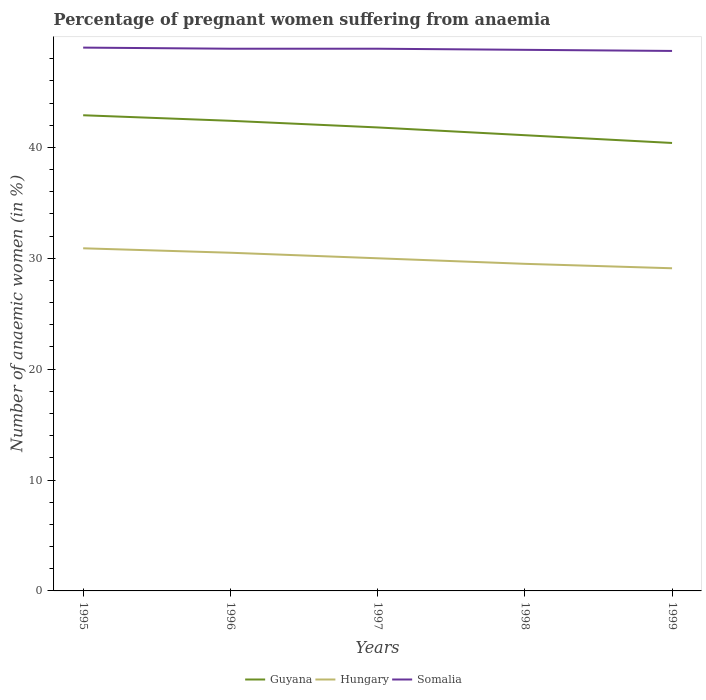How many different coloured lines are there?
Your answer should be very brief. 3. Is the number of lines equal to the number of legend labels?
Make the answer very short. Yes. Across all years, what is the maximum number of anaemic women in Somalia?
Make the answer very short. 48.7. In which year was the number of anaemic women in Somalia maximum?
Give a very brief answer. 1999. What is the total number of anaemic women in Guyana in the graph?
Make the answer very short. 1.1. What is the difference between the highest and the second highest number of anaemic women in Hungary?
Your answer should be very brief. 1.8. How many lines are there?
Provide a succinct answer. 3. Are the values on the major ticks of Y-axis written in scientific E-notation?
Give a very brief answer. No. Where does the legend appear in the graph?
Your answer should be compact. Bottom center. What is the title of the graph?
Keep it short and to the point. Percentage of pregnant women suffering from anaemia. Does "Tajikistan" appear as one of the legend labels in the graph?
Make the answer very short. No. What is the label or title of the X-axis?
Offer a very short reply. Years. What is the label or title of the Y-axis?
Your answer should be very brief. Number of anaemic women (in %). What is the Number of anaemic women (in %) in Guyana in 1995?
Your response must be concise. 42.9. What is the Number of anaemic women (in %) of Hungary in 1995?
Keep it short and to the point. 30.9. What is the Number of anaemic women (in %) in Guyana in 1996?
Keep it short and to the point. 42.4. What is the Number of anaemic women (in %) in Hungary in 1996?
Your answer should be very brief. 30.5. What is the Number of anaemic women (in %) of Somalia in 1996?
Your answer should be very brief. 48.9. What is the Number of anaemic women (in %) in Guyana in 1997?
Your answer should be compact. 41.8. What is the Number of anaemic women (in %) of Somalia in 1997?
Offer a terse response. 48.9. What is the Number of anaemic women (in %) of Guyana in 1998?
Your answer should be very brief. 41.1. What is the Number of anaemic women (in %) of Hungary in 1998?
Ensure brevity in your answer.  29.5. What is the Number of anaemic women (in %) in Somalia in 1998?
Offer a very short reply. 48.8. What is the Number of anaemic women (in %) of Guyana in 1999?
Make the answer very short. 40.4. What is the Number of anaemic women (in %) of Hungary in 1999?
Your answer should be compact. 29.1. What is the Number of anaemic women (in %) in Somalia in 1999?
Keep it short and to the point. 48.7. Across all years, what is the maximum Number of anaemic women (in %) of Guyana?
Your response must be concise. 42.9. Across all years, what is the maximum Number of anaemic women (in %) of Hungary?
Offer a very short reply. 30.9. Across all years, what is the maximum Number of anaemic women (in %) in Somalia?
Ensure brevity in your answer.  49. Across all years, what is the minimum Number of anaemic women (in %) in Guyana?
Keep it short and to the point. 40.4. Across all years, what is the minimum Number of anaemic women (in %) of Hungary?
Provide a succinct answer. 29.1. Across all years, what is the minimum Number of anaemic women (in %) of Somalia?
Make the answer very short. 48.7. What is the total Number of anaemic women (in %) of Guyana in the graph?
Ensure brevity in your answer.  208.6. What is the total Number of anaemic women (in %) in Hungary in the graph?
Ensure brevity in your answer.  150. What is the total Number of anaemic women (in %) in Somalia in the graph?
Keep it short and to the point. 244.3. What is the difference between the Number of anaemic women (in %) of Hungary in 1995 and that in 1996?
Keep it short and to the point. 0.4. What is the difference between the Number of anaemic women (in %) in Somalia in 1995 and that in 1996?
Offer a terse response. 0.1. What is the difference between the Number of anaemic women (in %) in Guyana in 1995 and that in 1997?
Provide a short and direct response. 1.1. What is the difference between the Number of anaemic women (in %) in Hungary in 1995 and that in 1997?
Keep it short and to the point. 0.9. What is the difference between the Number of anaemic women (in %) of Somalia in 1995 and that in 1997?
Make the answer very short. 0.1. What is the difference between the Number of anaemic women (in %) of Somalia in 1995 and that in 1998?
Make the answer very short. 0.2. What is the difference between the Number of anaemic women (in %) of Guyana in 1995 and that in 1999?
Ensure brevity in your answer.  2.5. What is the difference between the Number of anaemic women (in %) of Somalia in 1995 and that in 1999?
Make the answer very short. 0.3. What is the difference between the Number of anaemic women (in %) of Guyana in 1996 and that in 1997?
Ensure brevity in your answer.  0.6. What is the difference between the Number of anaemic women (in %) in Somalia in 1996 and that in 1997?
Your response must be concise. 0. What is the difference between the Number of anaemic women (in %) in Guyana in 1997 and that in 1998?
Offer a very short reply. 0.7. What is the difference between the Number of anaemic women (in %) in Hungary in 1997 and that in 1998?
Make the answer very short. 0.5. What is the difference between the Number of anaemic women (in %) in Hungary in 1997 and that in 1999?
Your answer should be compact. 0.9. What is the difference between the Number of anaemic women (in %) of Hungary in 1998 and that in 1999?
Give a very brief answer. 0.4. What is the difference between the Number of anaemic women (in %) of Somalia in 1998 and that in 1999?
Make the answer very short. 0.1. What is the difference between the Number of anaemic women (in %) of Guyana in 1995 and the Number of anaemic women (in %) of Hungary in 1996?
Provide a succinct answer. 12.4. What is the difference between the Number of anaemic women (in %) in Guyana in 1995 and the Number of anaemic women (in %) in Somalia in 1996?
Your response must be concise. -6. What is the difference between the Number of anaemic women (in %) of Guyana in 1995 and the Number of anaemic women (in %) of Somalia in 1997?
Provide a succinct answer. -6. What is the difference between the Number of anaemic women (in %) of Hungary in 1995 and the Number of anaemic women (in %) of Somalia in 1997?
Your answer should be very brief. -18. What is the difference between the Number of anaemic women (in %) in Guyana in 1995 and the Number of anaemic women (in %) in Hungary in 1998?
Keep it short and to the point. 13.4. What is the difference between the Number of anaemic women (in %) of Guyana in 1995 and the Number of anaemic women (in %) of Somalia in 1998?
Offer a terse response. -5.9. What is the difference between the Number of anaemic women (in %) of Hungary in 1995 and the Number of anaemic women (in %) of Somalia in 1998?
Offer a terse response. -17.9. What is the difference between the Number of anaemic women (in %) of Guyana in 1995 and the Number of anaemic women (in %) of Somalia in 1999?
Provide a succinct answer. -5.8. What is the difference between the Number of anaemic women (in %) in Hungary in 1995 and the Number of anaemic women (in %) in Somalia in 1999?
Provide a short and direct response. -17.8. What is the difference between the Number of anaemic women (in %) of Guyana in 1996 and the Number of anaemic women (in %) of Hungary in 1997?
Your answer should be very brief. 12.4. What is the difference between the Number of anaemic women (in %) of Hungary in 1996 and the Number of anaemic women (in %) of Somalia in 1997?
Provide a short and direct response. -18.4. What is the difference between the Number of anaemic women (in %) of Guyana in 1996 and the Number of anaemic women (in %) of Somalia in 1998?
Keep it short and to the point. -6.4. What is the difference between the Number of anaemic women (in %) of Hungary in 1996 and the Number of anaemic women (in %) of Somalia in 1998?
Provide a succinct answer. -18.3. What is the difference between the Number of anaemic women (in %) of Hungary in 1996 and the Number of anaemic women (in %) of Somalia in 1999?
Offer a terse response. -18.2. What is the difference between the Number of anaemic women (in %) of Hungary in 1997 and the Number of anaemic women (in %) of Somalia in 1998?
Your response must be concise. -18.8. What is the difference between the Number of anaemic women (in %) of Guyana in 1997 and the Number of anaemic women (in %) of Hungary in 1999?
Ensure brevity in your answer.  12.7. What is the difference between the Number of anaemic women (in %) in Guyana in 1997 and the Number of anaemic women (in %) in Somalia in 1999?
Your answer should be very brief. -6.9. What is the difference between the Number of anaemic women (in %) of Hungary in 1997 and the Number of anaemic women (in %) of Somalia in 1999?
Your answer should be very brief. -18.7. What is the difference between the Number of anaemic women (in %) in Guyana in 1998 and the Number of anaemic women (in %) in Hungary in 1999?
Provide a succinct answer. 12. What is the difference between the Number of anaemic women (in %) in Hungary in 1998 and the Number of anaemic women (in %) in Somalia in 1999?
Provide a short and direct response. -19.2. What is the average Number of anaemic women (in %) in Guyana per year?
Provide a succinct answer. 41.72. What is the average Number of anaemic women (in %) in Somalia per year?
Give a very brief answer. 48.86. In the year 1995, what is the difference between the Number of anaemic women (in %) of Guyana and Number of anaemic women (in %) of Somalia?
Give a very brief answer. -6.1. In the year 1995, what is the difference between the Number of anaemic women (in %) of Hungary and Number of anaemic women (in %) of Somalia?
Provide a succinct answer. -18.1. In the year 1996, what is the difference between the Number of anaemic women (in %) of Hungary and Number of anaemic women (in %) of Somalia?
Offer a very short reply. -18.4. In the year 1997, what is the difference between the Number of anaemic women (in %) in Guyana and Number of anaemic women (in %) in Somalia?
Your response must be concise. -7.1. In the year 1997, what is the difference between the Number of anaemic women (in %) in Hungary and Number of anaemic women (in %) in Somalia?
Your response must be concise. -18.9. In the year 1998, what is the difference between the Number of anaemic women (in %) of Guyana and Number of anaemic women (in %) of Hungary?
Provide a short and direct response. 11.6. In the year 1998, what is the difference between the Number of anaemic women (in %) in Hungary and Number of anaemic women (in %) in Somalia?
Provide a short and direct response. -19.3. In the year 1999, what is the difference between the Number of anaemic women (in %) of Guyana and Number of anaemic women (in %) of Hungary?
Make the answer very short. 11.3. In the year 1999, what is the difference between the Number of anaemic women (in %) of Hungary and Number of anaemic women (in %) of Somalia?
Give a very brief answer. -19.6. What is the ratio of the Number of anaemic women (in %) of Guyana in 1995 to that in 1996?
Your answer should be compact. 1.01. What is the ratio of the Number of anaemic women (in %) of Hungary in 1995 to that in 1996?
Your response must be concise. 1.01. What is the ratio of the Number of anaemic women (in %) in Somalia in 1995 to that in 1996?
Offer a very short reply. 1. What is the ratio of the Number of anaemic women (in %) in Guyana in 1995 to that in 1997?
Offer a terse response. 1.03. What is the ratio of the Number of anaemic women (in %) in Somalia in 1995 to that in 1997?
Make the answer very short. 1. What is the ratio of the Number of anaemic women (in %) in Guyana in 1995 to that in 1998?
Keep it short and to the point. 1.04. What is the ratio of the Number of anaemic women (in %) in Hungary in 1995 to that in 1998?
Offer a terse response. 1.05. What is the ratio of the Number of anaemic women (in %) in Somalia in 1995 to that in 1998?
Offer a terse response. 1. What is the ratio of the Number of anaemic women (in %) in Guyana in 1995 to that in 1999?
Your answer should be compact. 1.06. What is the ratio of the Number of anaemic women (in %) of Hungary in 1995 to that in 1999?
Provide a succinct answer. 1.06. What is the ratio of the Number of anaemic women (in %) in Somalia in 1995 to that in 1999?
Your response must be concise. 1.01. What is the ratio of the Number of anaemic women (in %) of Guyana in 1996 to that in 1997?
Offer a terse response. 1.01. What is the ratio of the Number of anaemic women (in %) of Hungary in 1996 to that in 1997?
Your answer should be compact. 1.02. What is the ratio of the Number of anaemic women (in %) in Somalia in 1996 to that in 1997?
Give a very brief answer. 1. What is the ratio of the Number of anaemic women (in %) in Guyana in 1996 to that in 1998?
Offer a very short reply. 1.03. What is the ratio of the Number of anaemic women (in %) of Hungary in 1996 to that in 1998?
Offer a terse response. 1.03. What is the ratio of the Number of anaemic women (in %) in Guyana in 1996 to that in 1999?
Make the answer very short. 1.05. What is the ratio of the Number of anaemic women (in %) of Hungary in 1996 to that in 1999?
Your response must be concise. 1.05. What is the ratio of the Number of anaemic women (in %) of Hungary in 1997 to that in 1998?
Offer a very short reply. 1.02. What is the ratio of the Number of anaemic women (in %) of Guyana in 1997 to that in 1999?
Offer a very short reply. 1.03. What is the ratio of the Number of anaemic women (in %) of Hungary in 1997 to that in 1999?
Your answer should be very brief. 1.03. What is the ratio of the Number of anaemic women (in %) in Somalia in 1997 to that in 1999?
Give a very brief answer. 1. What is the ratio of the Number of anaemic women (in %) of Guyana in 1998 to that in 1999?
Ensure brevity in your answer.  1.02. What is the ratio of the Number of anaemic women (in %) in Hungary in 1998 to that in 1999?
Provide a short and direct response. 1.01. What is the ratio of the Number of anaemic women (in %) in Somalia in 1998 to that in 1999?
Your answer should be very brief. 1. What is the difference between the highest and the lowest Number of anaemic women (in %) of Guyana?
Ensure brevity in your answer.  2.5. What is the difference between the highest and the lowest Number of anaemic women (in %) of Hungary?
Provide a succinct answer. 1.8. What is the difference between the highest and the lowest Number of anaemic women (in %) in Somalia?
Your response must be concise. 0.3. 